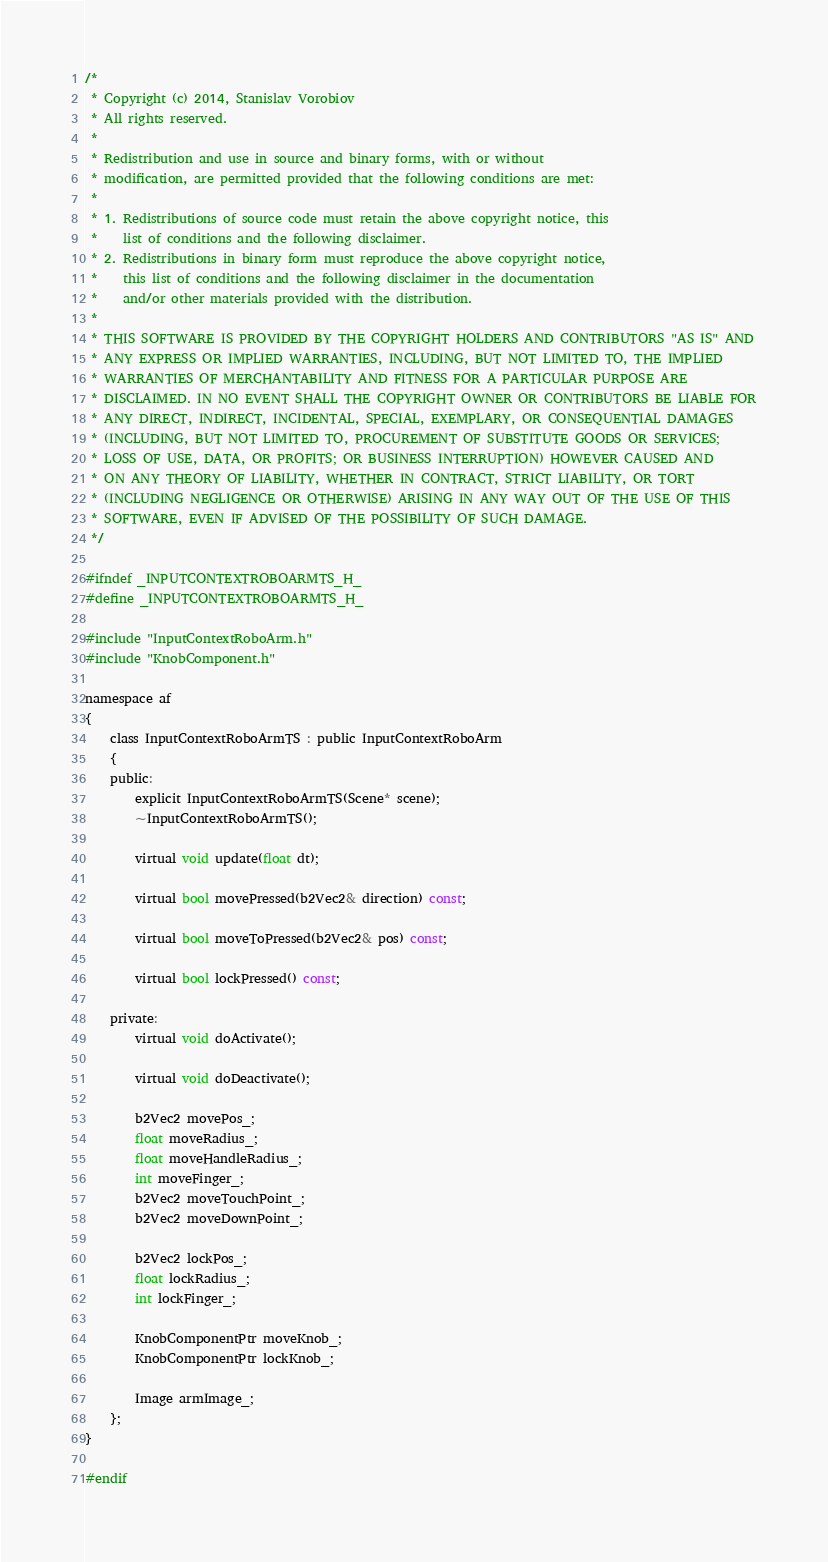Convert code to text. <code><loc_0><loc_0><loc_500><loc_500><_C_>/*
 * Copyright (c) 2014, Stanislav Vorobiov
 * All rights reserved.
 *
 * Redistribution and use in source and binary forms, with or without
 * modification, are permitted provided that the following conditions are met:
 *
 * 1. Redistributions of source code must retain the above copyright notice, this
 *    list of conditions and the following disclaimer.
 * 2. Redistributions in binary form must reproduce the above copyright notice,
 *    this list of conditions and the following disclaimer in the documentation
 *    and/or other materials provided with the distribution.
 *
 * THIS SOFTWARE IS PROVIDED BY THE COPYRIGHT HOLDERS AND CONTRIBUTORS "AS IS" AND
 * ANY EXPRESS OR IMPLIED WARRANTIES, INCLUDING, BUT NOT LIMITED TO, THE IMPLIED
 * WARRANTIES OF MERCHANTABILITY AND FITNESS FOR A PARTICULAR PURPOSE ARE
 * DISCLAIMED. IN NO EVENT SHALL THE COPYRIGHT OWNER OR CONTRIBUTORS BE LIABLE FOR
 * ANY DIRECT, INDIRECT, INCIDENTAL, SPECIAL, EXEMPLARY, OR CONSEQUENTIAL DAMAGES
 * (INCLUDING, BUT NOT LIMITED TO, PROCUREMENT OF SUBSTITUTE GOODS OR SERVICES;
 * LOSS OF USE, DATA, OR PROFITS; OR BUSINESS INTERRUPTION) HOWEVER CAUSED AND
 * ON ANY THEORY OF LIABILITY, WHETHER IN CONTRACT, STRICT LIABILITY, OR TORT
 * (INCLUDING NEGLIGENCE OR OTHERWISE) ARISING IN ANY WAY OUT OF THE USE OF THIS
 * SOFTWARE, EVEN IF ADVISED OF THE POSSIBILITY OF SUCH DAMAGE.
 */

#ifndef _INPUTCONTEXTROBOARMTS_H_
#define _INPUTCONTEXTROBOARMTS_H_

#include "InputContextRoboArm.h"
#include "KnobComponent.h"

namespace af
{
    class InputContextRoboArmTS : public InputContextRoboArm
    {
    public:
        explicit InputContextRoboArmTS(Scene* scene);
        ~InputContextRoboArmTS();

        virtual void update(float dt);

        virtual bool movePressed(b2Vec2& direction) const;

        virtual bool moveToPressed(b2Vec2& pos) const;

        virtual bool lockPressed() const;

    private:
        virtual void doActivate();

        virtual void doDeactivate();

        b2Vec2 movePos_;
        float moveRadius_;
        float moveHandleRadius_;
        int moveFinger_;
        b2Vec2 moveTouchPoint_;
        b2Vec2 moveDownPoint_;

        b2Vec2 lockPos_;
        float lockRadius_;
        int lockFinger_;

        KnobComponentPtr moveKnob_;
        KnobComponentPtr lockKnob_;

        Image armImage_;
    };
}

#endif
</code> 